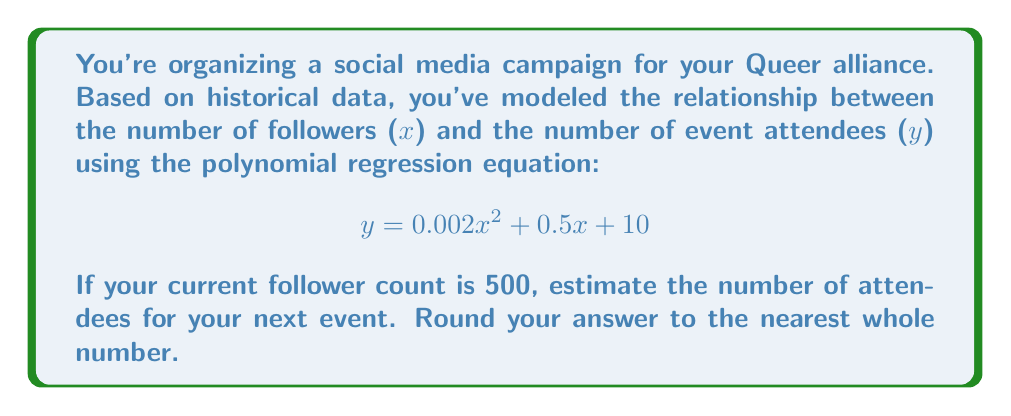Teach me how to tackle this problem. To solve this problem, we'll follow these steps:

1. Identify the given polynomial regression equation:
   $y = 0.002x^2 + 0.5x + 10$

2. Substitute the current follower count (x = 500) into the equation:
   $y = 0.002(500)^2 + 0.5(500) + 10$

3. Simplify the equation:
   $y = 0.002(250000) + 250 + 10$
   $y = 500 + 250 + 10$

4. Calculate the result:
   $y = 760$

5. Round to the nearest whole number:
   760 is already a whole number, so no rounding is necessary.

Therefore, based on the polynomial regression model, you can expect approximately 760 attendees for your next event.
Answer: 760 attendees 